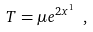Convert formula to latex. <formula><loc_0><loc_0><loc_500><loc_500>T = \mu e ^ { 2 x ^ { 1 } } \ ,</formula> 